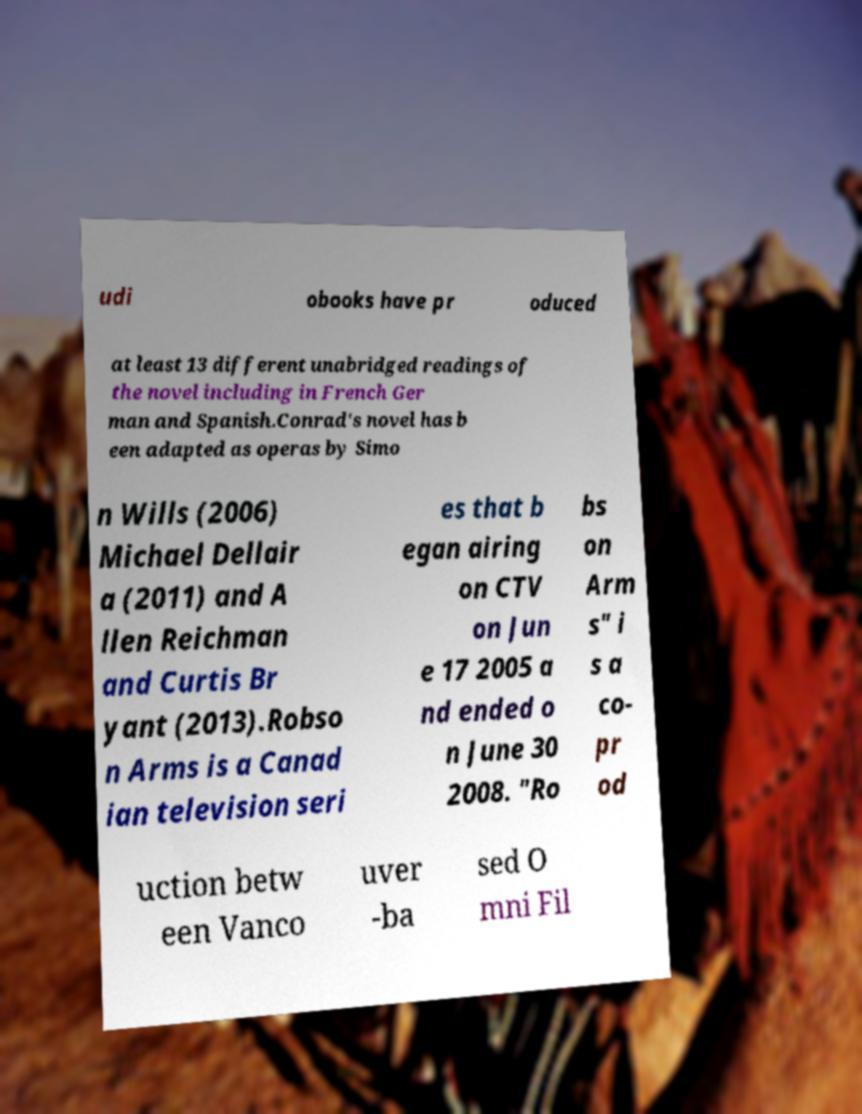Can you accurately transcribe the text from the provided image for me? udi obooks have pr oduced at least 13 different unabridged readings of the novel including in French Ger man and Spanish.Conrad's novel has b een adapted as operas by Simo n Wills (2006) Michael Dellair a (2011) and A llen Reichman and Curtis Br yant (2013).Robso n Arms is a Canad ian television seri es that b egan airing on CTV on Jun e 17 2005 a nd ended o n June 30 2008. "Ro bs on Arm s" i s a co- pr od uction betw een Vanco uver -ba sed O mni Fil 